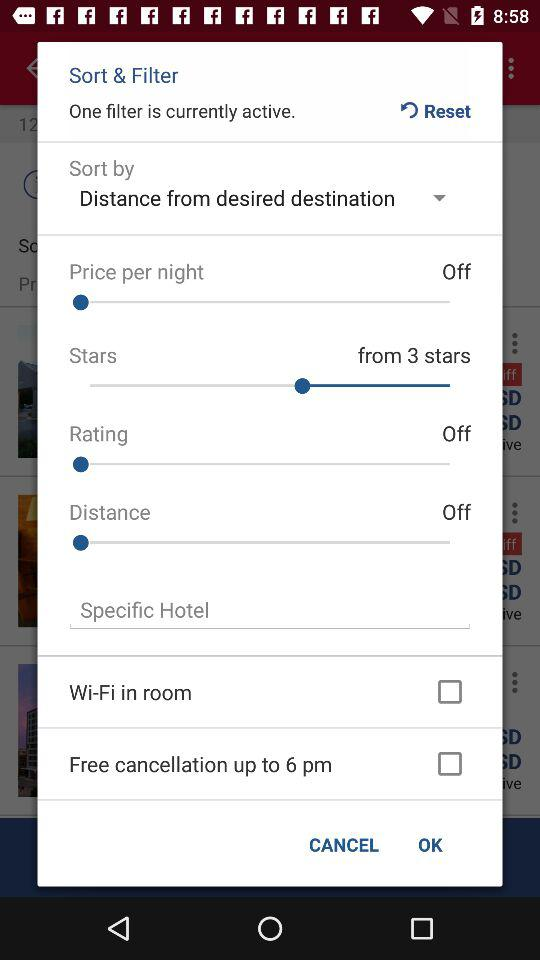How many filters are currently active?
Answer the question using a single word or phrase. 1 